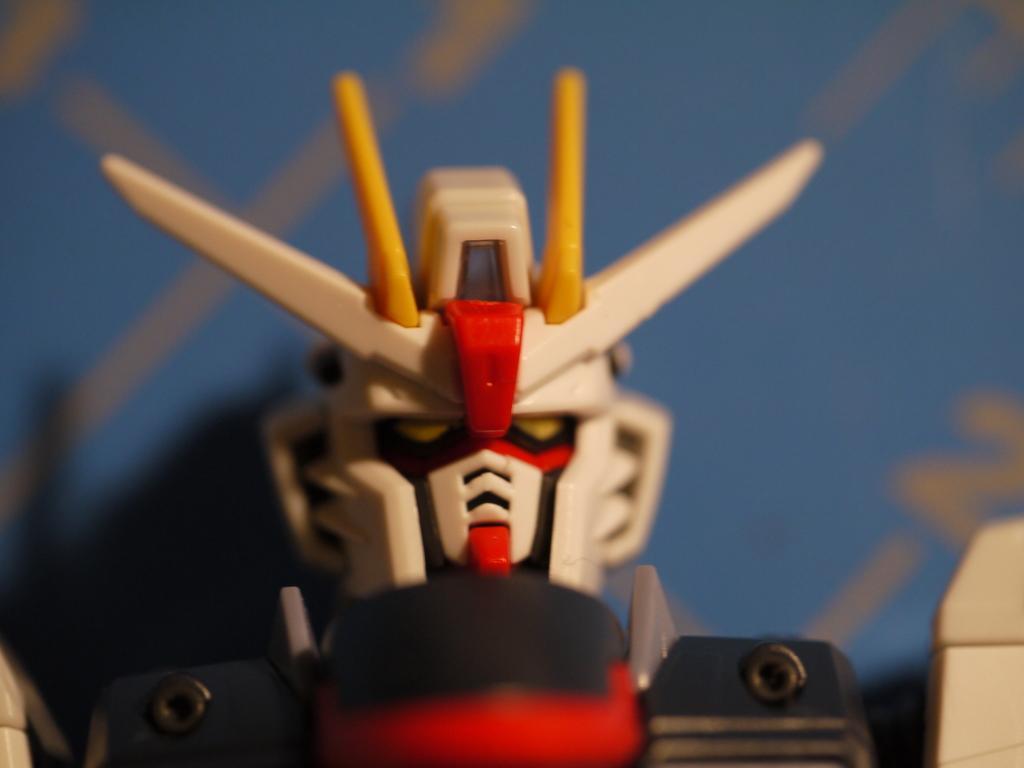In one or two sentences, can you explain what this image depicts? In this image I can see a toy. The background is blurred. 